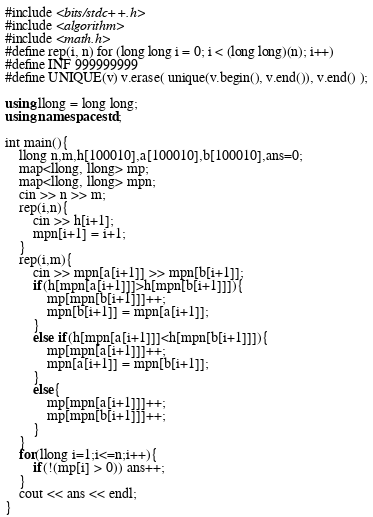<code> <loc_0><loc_0><loc_500><loc_500><_C++_>#include <bits/stdc++.h>
#include <algorithm>
#include <math.h>
#define rep(i, n) for (long long i = 0; i < (long long)(n); i++)
#define INF 999999999
#define UNIQUE(v) v.erase( unique(v.begin(), v.end()), v.end() );

using llong = long long;
using namespace std;

int main(){
    llong n,m,h[100010],a[100010],b[100010],ans=0;
    map<llong, llong> mp;
    map<llong, llong> mpn;
    cin >> n >> m;
    rep(i,n){
        cin >> h[i+1];
        mpn[i+1] = i+1;
    }
    rep(i,m){
        cin >> mpn[a[i+1]] >> mpn[b[i+1]];
        if(h[mpn[a[i+1]]]>h[mpn[b[i+1]]]){
            mp[mpn[b[i+1]]]++;
            mpn[b[i+1]] = mpn[a[i+1]];
        }
        else if(h[mpn[a[i+1]]]<h[mpn[b[i+1]]]){
            mp[mpn[a[i+1]]]++;
            mpn[a[i+1]] = mpn[b[i+1]];
        }
        else{
            mp[mpn[a[i+1]]]++;
            mp[mpn[b[i+1]]]++;
        }
    }
    for(llong i=1;i<=n;i++){
        if(!(mp[i] > 0)) ans++;
    }
    cout << ans << endl;
}</code> 